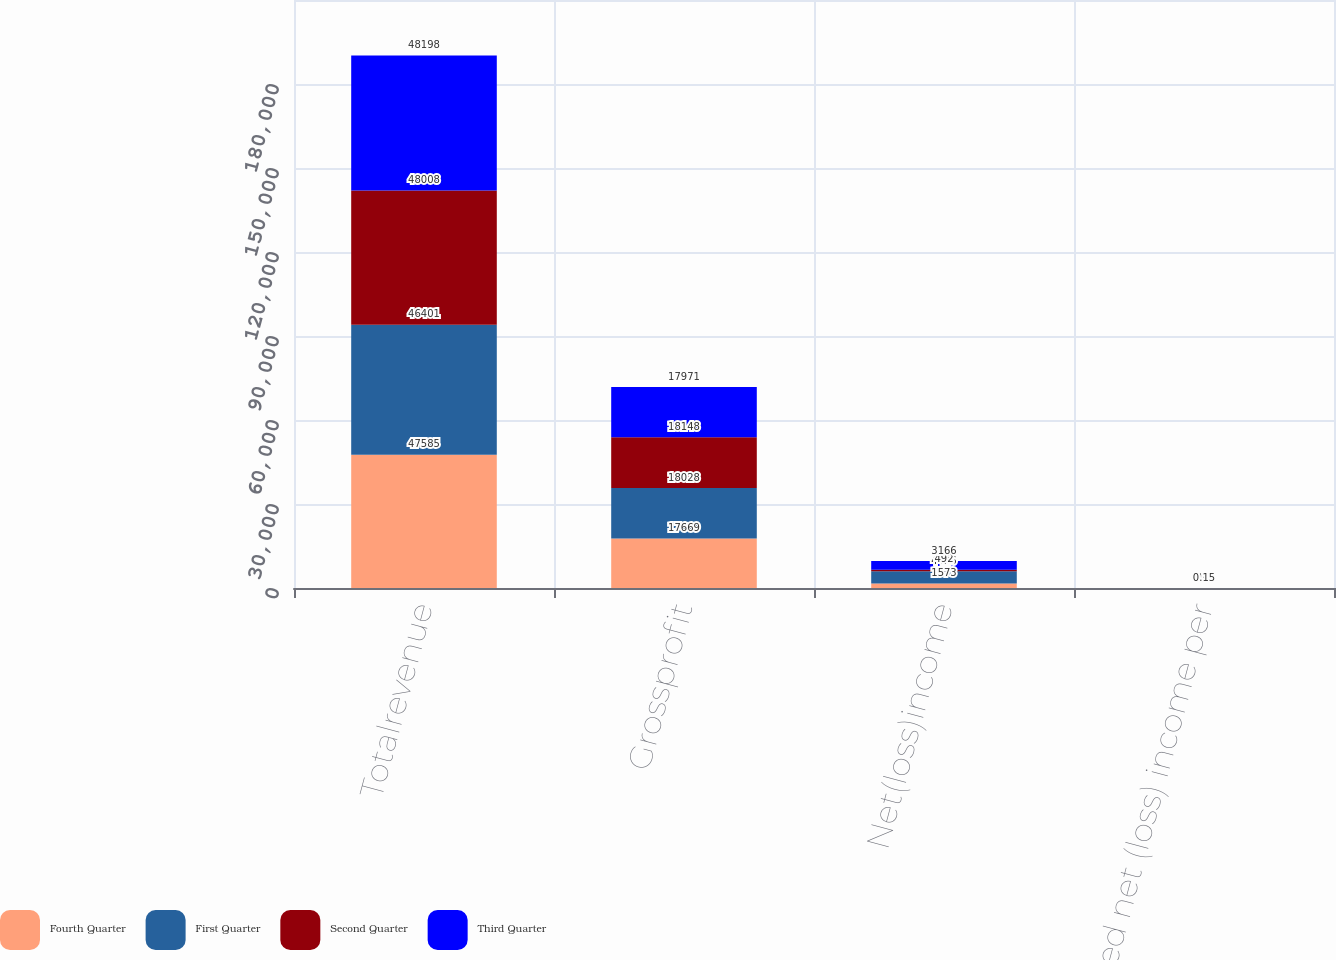<chart> <loc_0><loc_0><loc_500><loc_500><stacked_bar_chart><ecel><fcel>Totalrevenue<fcel>Grossprofit<fcel>Net(loss)income<fcel>Diluted net (loss) income per<nl><fcel>Fourth Quarter<fcel>47585<fcel>17669<fcel>1573<fcel>0.1<nl><fcel>First Quarter<fcel>46401<fcel>18028<fcel>4426<fcel>0.22<nl><fcel>Second Quarter<fcel>48008<fcel>18148<fcel>492<fcel>0.02<nl><fcel>Third Quarter<fcel>48198<fcel>17971<fcel>3166<fcel>0.15<nl></chart> 